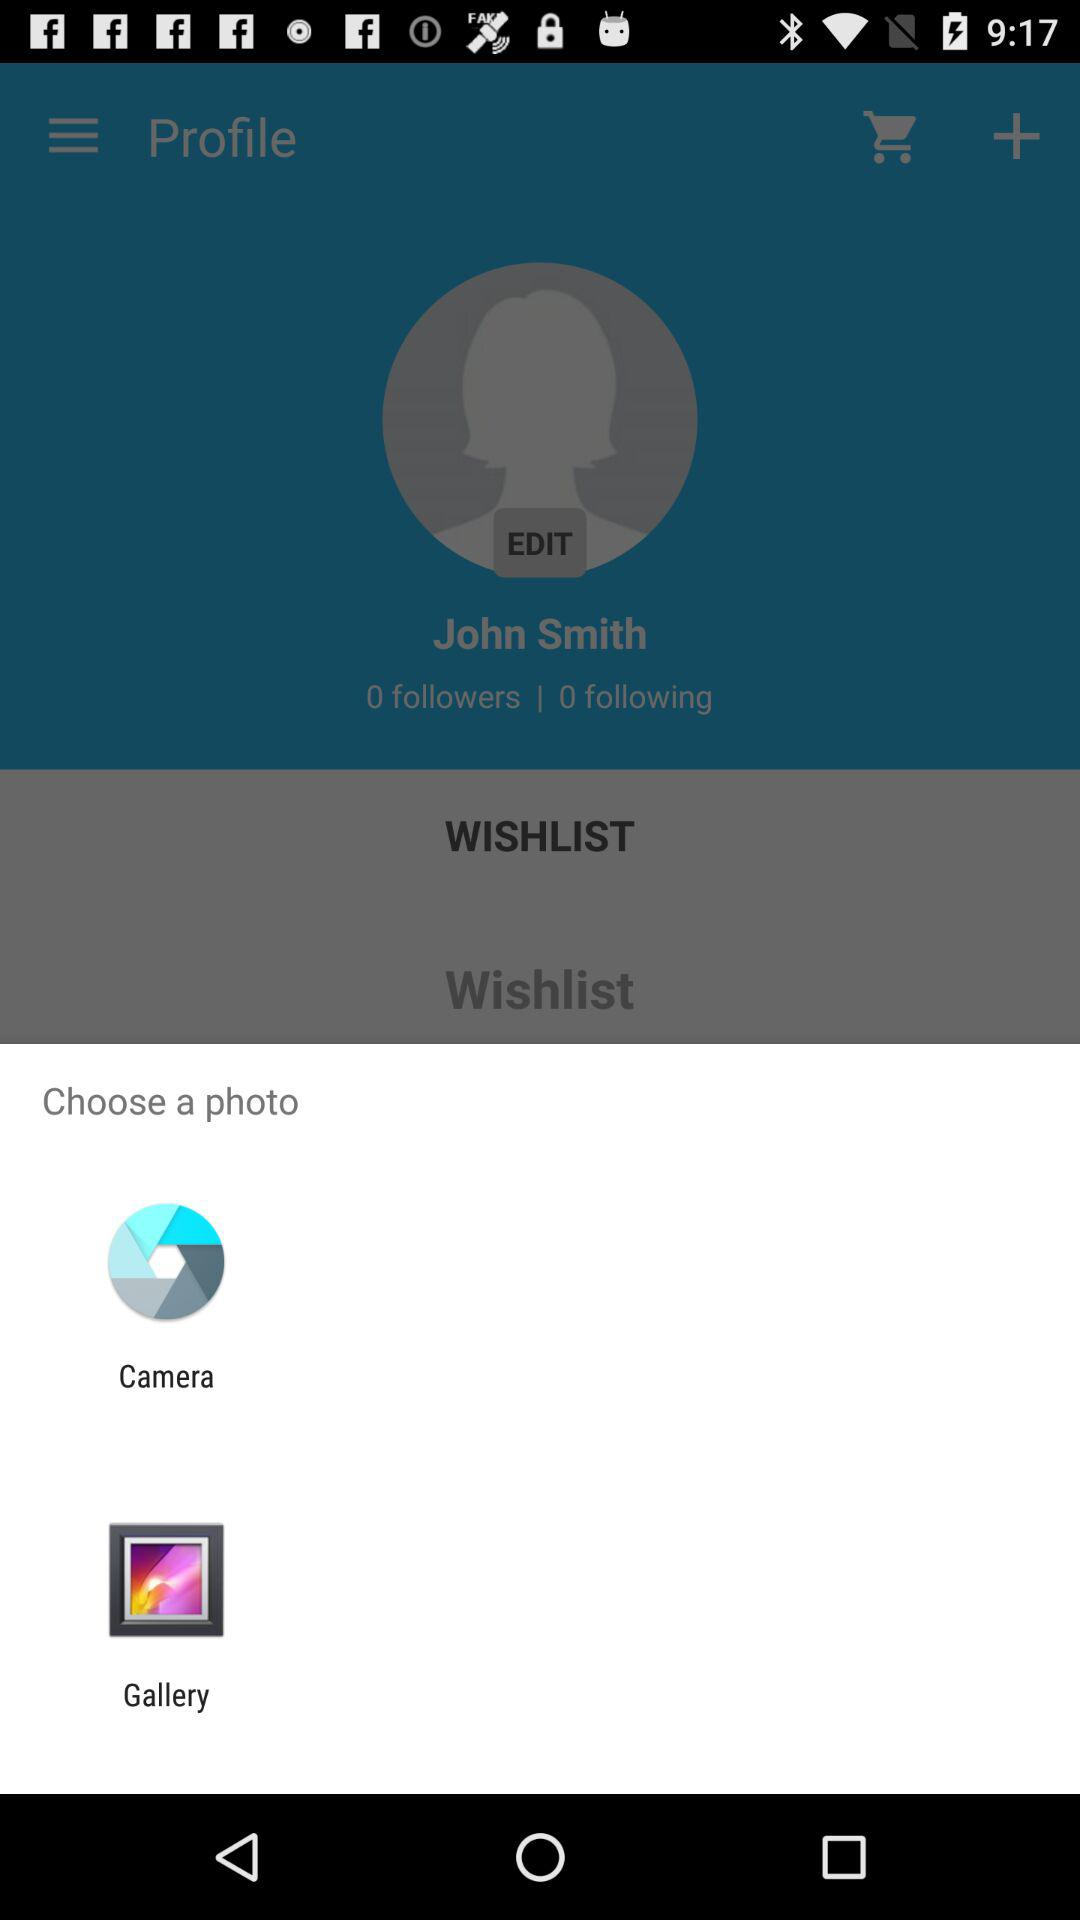How many people are following John Smith? There are 0 people following John Smith. 